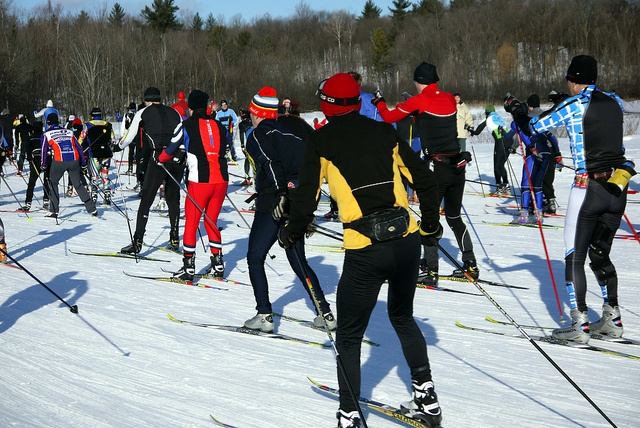Describe the objects in this image and their specific colors. I can see people in gray, black, lightgray, and gold tones, people in gray, black, lightgray, and darkgray tones, people in gray, black, lightgray, and navy tones, people in gray, black, lightgray, and darkgray tones, and people in gray, black, red, and brown tones in this image. 